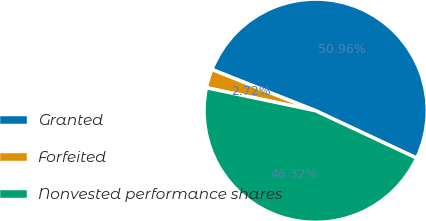Convert chart. <chart><loc_0><loc_0><loc_500><loc_500><pie_chart><fcel>Granted<fcel>Forfeited<fcel>Nonvested performance shares<nl><fcel>50.95%<fcel>2.72%<fcel>46.32%<nl></chart> 